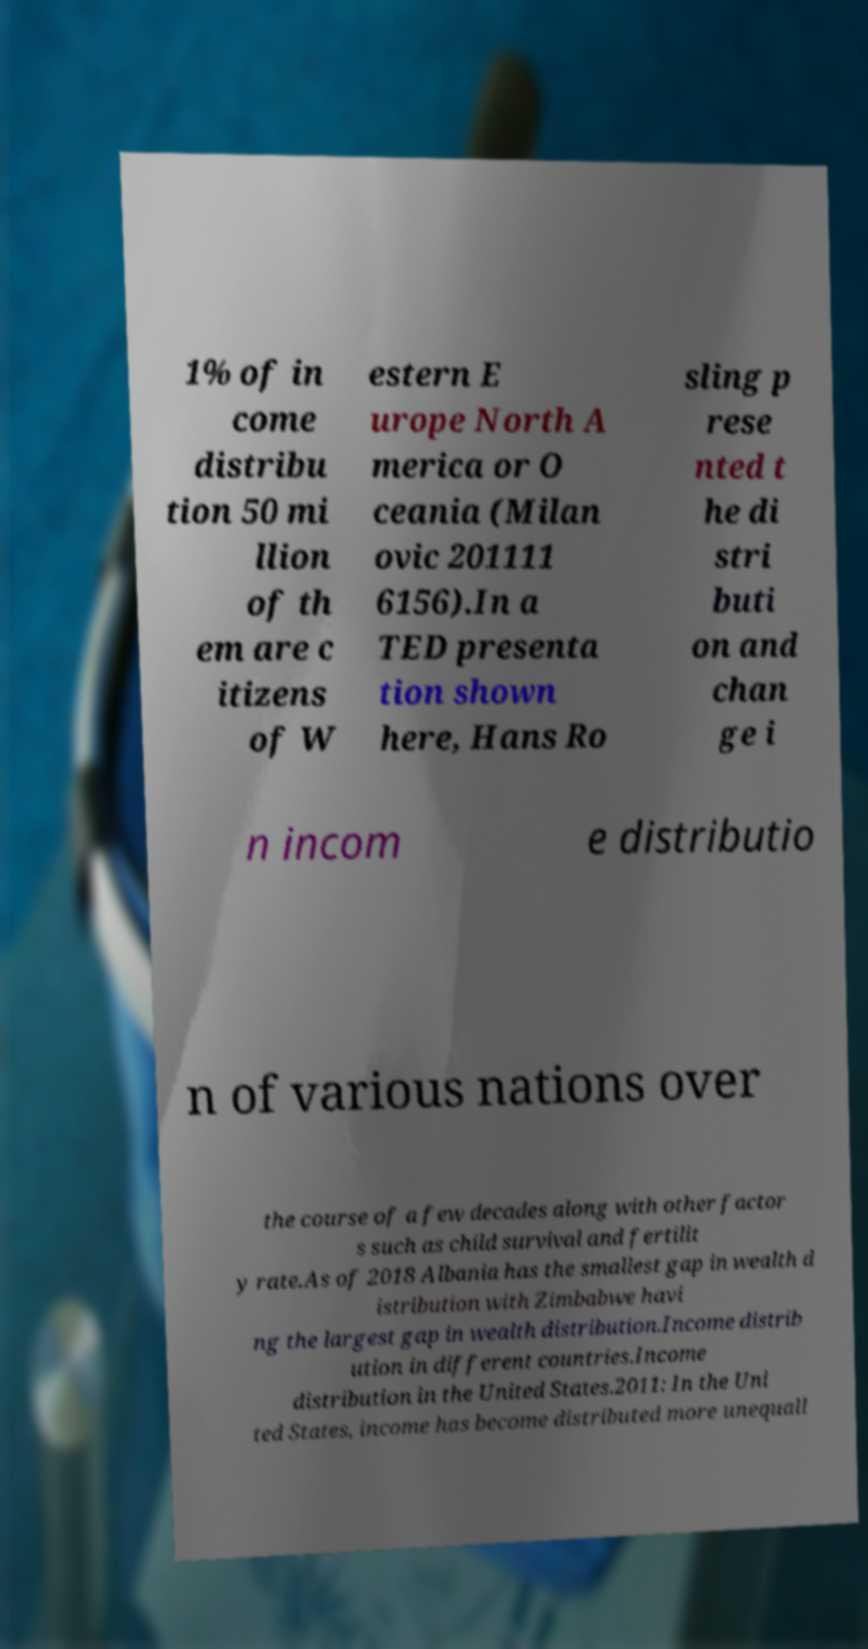Please identify and transcribe the text found in this image. 1% of in come distribu tion 50 mi llion of th em are c itizens of W estern E urope North A merica or O ceania (Milan ovic 201111 6156).In a TED presenta tion shown here, Hans Ro sling p rese nted t he di stri buti on and chan ge i n incom e distributio n of various nations over the course of a few decades along with other factor s such as child survival and fertilit y rate.As of 2018 Albania has the smallest gap in wealth d istribution with Zimbabwe havi ng the largest gap in wealth distribution.Income distrib ution in different countries.Income distribution in the United States.2011: In the Uni ted States, income has become distributed more unequall 